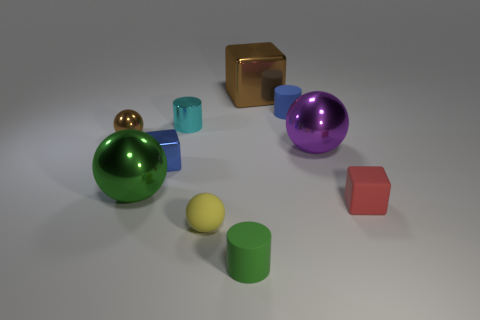Do the large metallic block and the tiny metal ball have the same color?
Your answer should be very brief. Yes. Is the large purple object made of the same material as the red thing?
Give a very brief answer. No. How many objects are either rubber cylinders that are behind the brown ball or tiny blue objects that are on the right side of the green cylinder?
Give a very brief answer. 1. Is there a gray rubber thing of the same size as the cyan metal thing?
Your answer should be compact. No. There is a small metal thing that is the same shape as the tiny red rubber thing; what is its color?
Make the answer very short. Blue. Is there a small cube that is in front of the brown metallic object to the right of the yellow sphere?
Provide a short and direct response. Yes. There is a blue object that is in front of the brown metallic sphere; does it have the same shape as the purple shiny object?
Offer a very short reply. No. The small yellow thing is what shape?
Ensure brevity in your answer.  Sphere. How many cubes have the same material as the big green thing?
Keep it short and to the point. 2. There is a small metal ball; is it the same color as the cube that is behind the large purple ball?
Keep it short and to the point. Yes. 